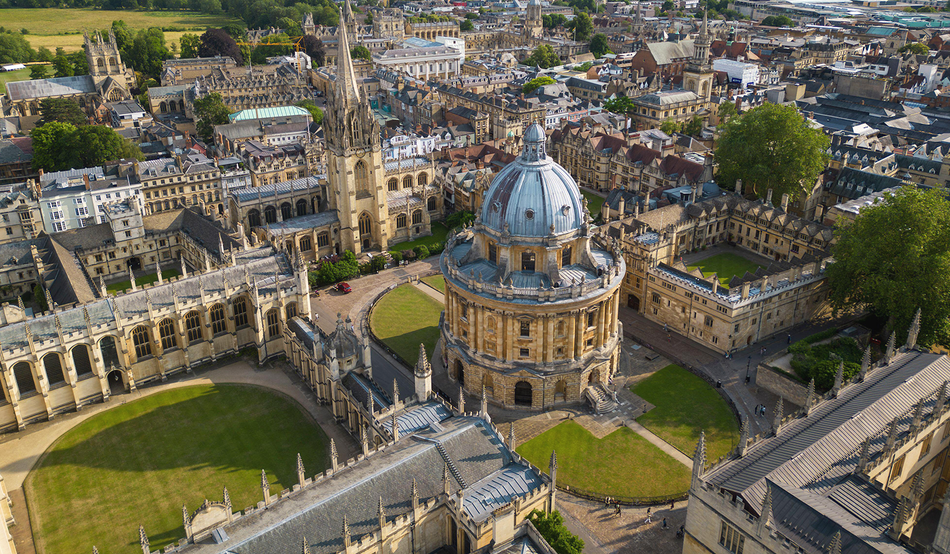If you could step into the image, what would you do or explore first? If I could step into this image, I would first explore the Radcliffe Camera. Its historical significance and breathtaking architecture make it a fascinating starting point. Walking inside, I would marvel at the collection of books and the scholarly aura that permeates the space. After that, I would stroll through the surrounding courtyards, taking in the beautiful gardens and the intricate details of the neighboring buildings. Each corner of the campus seems to tell a story, reflecting centuries of academic pursuit and excellence. 